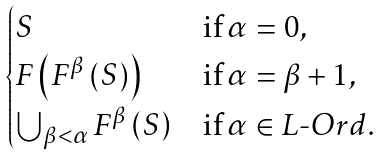Convert formula to latex. <formula><loc_0><loc_0><loc_500><loc_500>\begin{cases} S & \text {if} \, \alpha = 0 , \\ { F \left ( F ^ { \beta } \left ( S \right ) \right ) } & \text {if} \, \alpha = \beta + 1 , \\ { \bigcup _ { \beta < \alpha } { F ^ { \beta } \left ( S \right ) } } & \text {if} \, \alpha \in { L \text {-} O r d } . \end{cases}</formula> 